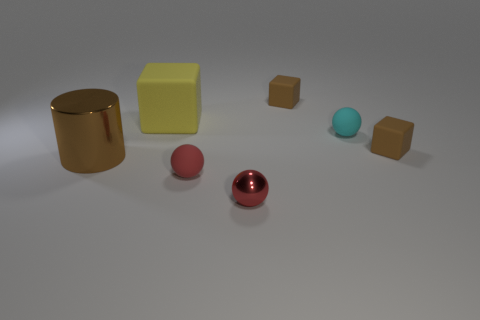Subtract all purple cubes. How many red spheres are left? 2 Subtract all tiny red spheres. How many spheres are left? 1 Subtract 1 spheres. How many spheres are left? 2 Add 1 gray metallic spheres. How many objects exist? 8 Subtract all cylinders. How many objects are left? 6 Subtract all brown balls. Subtract all purple blocks. How many balls are left? 3 Subtract all brown metal objects. Subtract all matte things. How many objects are left? 1 Add 2 tiny matte things. How many tiny matte things are left? 6 Add 5 tiny red rubber balls. How many tiny red rubber balls exist? 6 Subtract 1 cyan spheres. How many objects are left? 6 